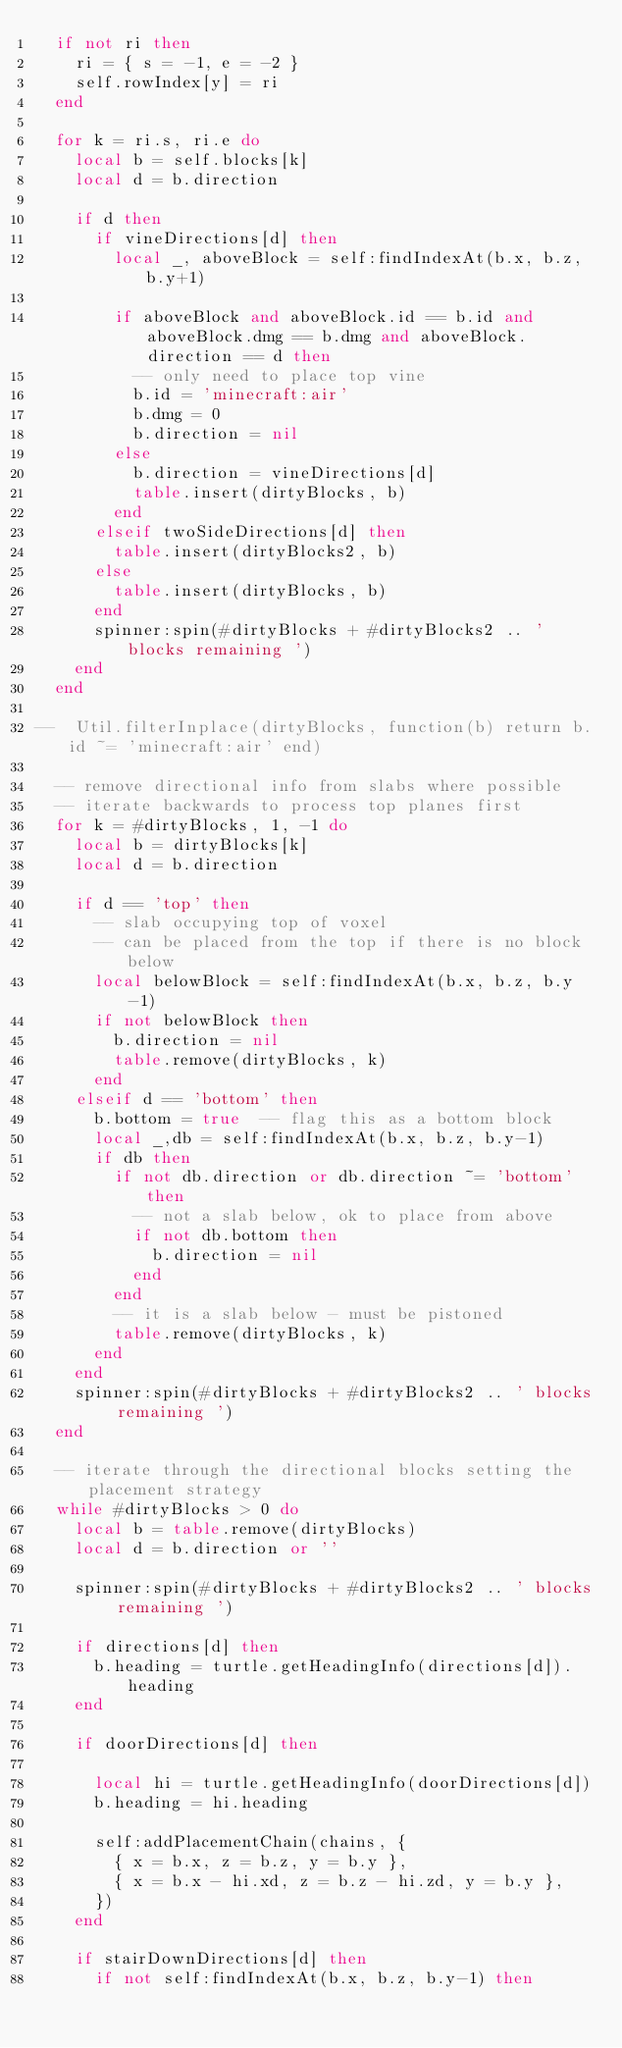<code> <loc_0><loc_0><loc_500><loc_500><_Lua_>  if not ri then
    ri = { s = -1, e = -2 }
    self.rowIndex[y] = ri
  end

  for k = ri.s, ri.e do
    local b = self.blocks[k]
    local d = b.direction

    if d then
      if vineDirections[d] then
        local _, aboveBlock = self:findIndexAt(b.x, b.z, b.y+1)

        if aboveBlock and aboveBlock.id == b.id and aboveBlock.dmg == b.dmg and aboveBlock.direction == d then
          -- only need to place top vine
          b.id = 'minecraft:air'
          b.dmg = 0
          b.direction = nil
        else
          b.direction = vineDirections[d]
          table.insert(dirtyBlocks, b)
        end
      elseif twoSideDirections[d] then
        table.insert(dirtyBlocks2, b)
      else
        table.insert(dirtyBlocks, b)
      end
      spinner:spin(#dirtyBlocks + #dirtyBlocks2 .. ' blocks remaining ')
    end
  end

--  Util.filterInplace(dirtyBlocks, function(b) return b.id ~= 'minecraft:air' end)

  -- remove directional info from slabs where possible
  -- iterate backwards to process top planes first
  for k = #dirtyBlocks, 1, -1 do
    local b = dirtyBlocks[k]
    local d = b.direction

    if d == 'top' then
      -- slab occupying top of voxel
      -- can be placed from the top if there is no block below
      local belowBlock = self:findIndexAt(b.x, b.z, b.y-1)
      if not belowBlock then
        b.direction = nil
        table.remove(dirtyBlocks, k)
      end
    elseif d == 'bottom' then
      b.bottom = true  -- flag this as a bottom block
      local _,db = self:findIndexAt(b.x, b.z, b.y-1)
      if db then
        if not db.direction or db.direction ~= 'bottom' then
          -- not a slab below, ok to place from above
          if not db.bottom then
            b.direction = nil
          end
        end
        -- it is a slab below - must be pistoned
        table.remove(dirtyBlocks, k)
      end
    end
    spinner:spin(#dirtyBlocks + #dirtyBlocks2 .. ' blocks remaining ')
  end

  -- iterate through the directional blocks setting the placement strategy
  while #dirtyBlocks > 0 do
    local b = table.remove(dirtyBlocks)
    local d = b.direction or ''

    spinner:spin(#dirtyBlocks + #dirtyBlocks2 .. ' blocks remaining ')

    if directions[d] then
      b.heading = turtle.getHeadingInfo(directions[d]).heading
    end

    if doorDirections[d] then

      local hi = turtle.getHeadingInfo(doorDirections[d])
      b.heading = hi.heading

      self:addPlacementChain(chains, {
        { x = b.x, z = b.z, y = b.y },
        { x = b.x - hi.xd, z = b.z - hi.zd, y = b.y },
      })
    end

    if stairDownDirections[d] then
      if not self:findIndexAt(b.x, b.z, b.y-1) then</code> 